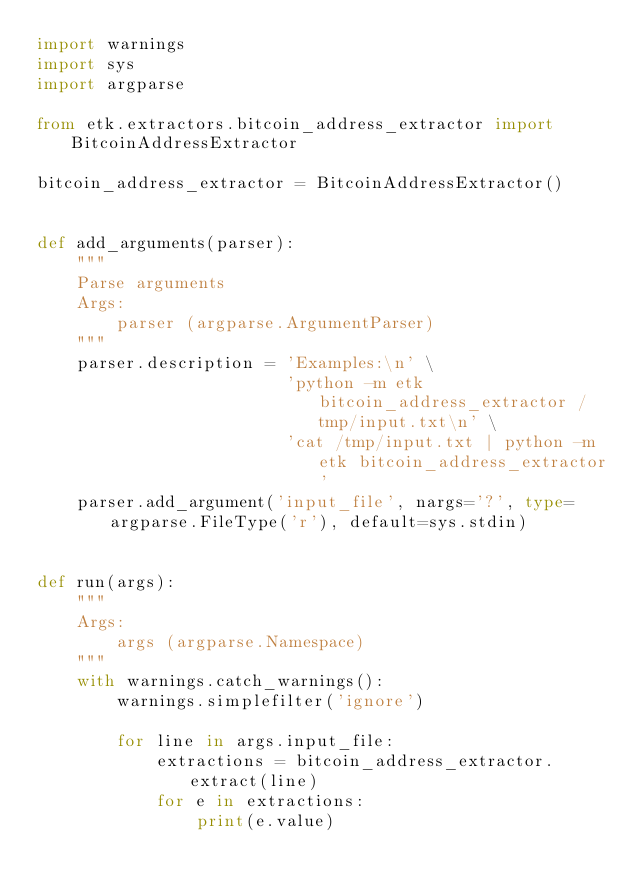<code> <loc_0><loc_0><loc_500><loc_500><_Python_>import warnings
import sys
import argparse

from etk.extractors.bitcoin_address_extractor import BitcoinAddressExtractor

bitcoin_address_extractor = BitcoinAddressExtractor()


def add_arguments(parser):
    """
    Parse arguments
    Args:
        parser (argparse.ArgumentParser)
    """
    parser.description = 'Examples:\n' \
                         'python -m etk bitcoin_address_extractor /tmp/input.txt\n' \
                         'cat /tmp/input.txt | python -m etk bitcoin_address_extractor'
    parser.add_argument('input_file', nargs='?', type=argparse.FileType('r'), default=sys.stdin)


def run(args):
    """
    Args:
        args (argparse.Namespace)
    """
    with warnings.catch_warnings():
        warnings.simplefilter('ignore')

        for line in args.input_file:
            extractions = bitcoin_address_extractor.extract(line)
            for e in extractions:
                print(e.value)
</code> 